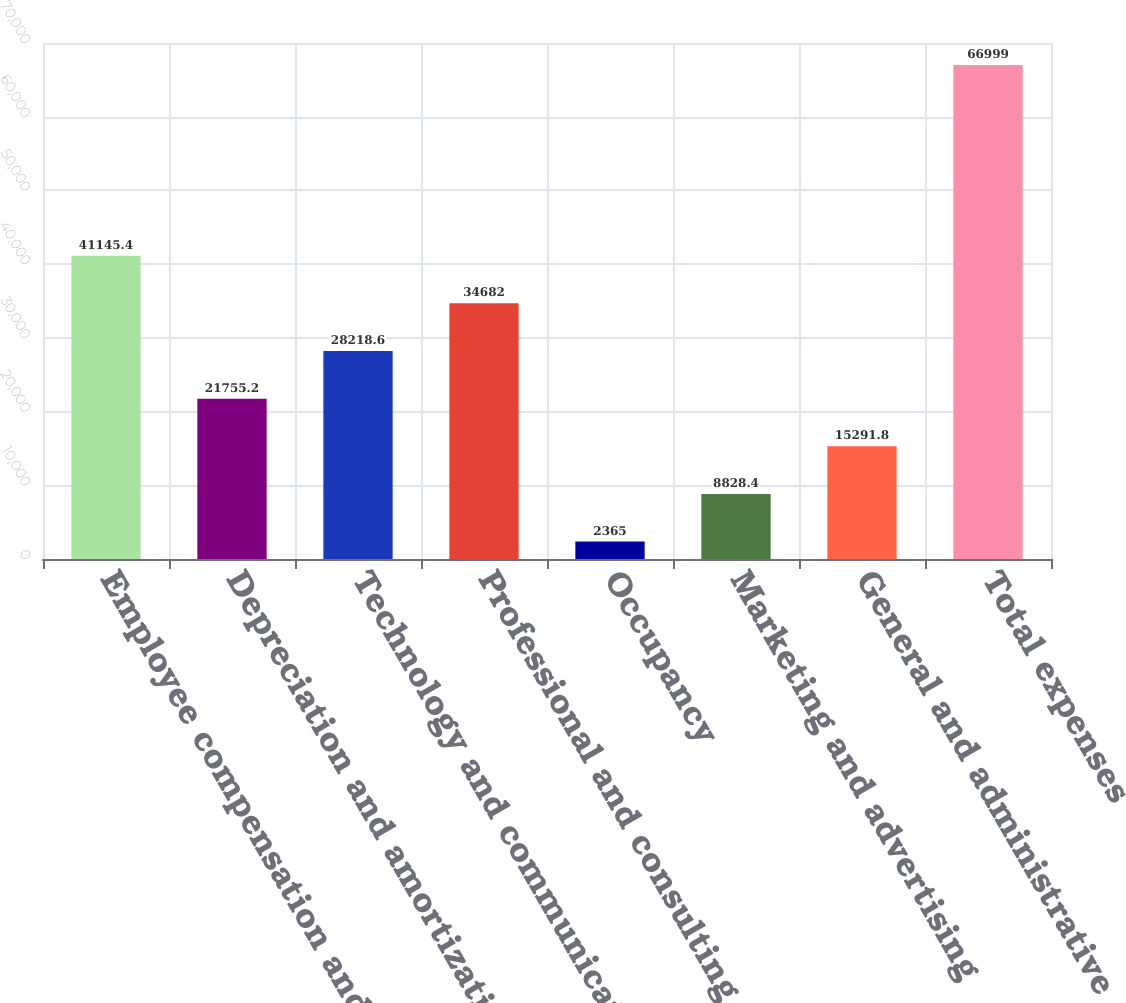<chart> <loc_0><loc_0><loc_500><loc_500><bar_chart><fcel>Employee compensation and<fcel>Depreciation and amortization<fcel>Technology and communications<fcel>Professional and consulting<fcel>Occupancy<fcel>Marketing and advertising<fcel>General and administrative<fcel>Total expenses<nl><fcel>41145.4<fcel>21755.2<fcel>28218.6<fcel>34682<fcel>2365<fcel>8828.4<fcel>15291.8<fcel>66999<nl></chart> 